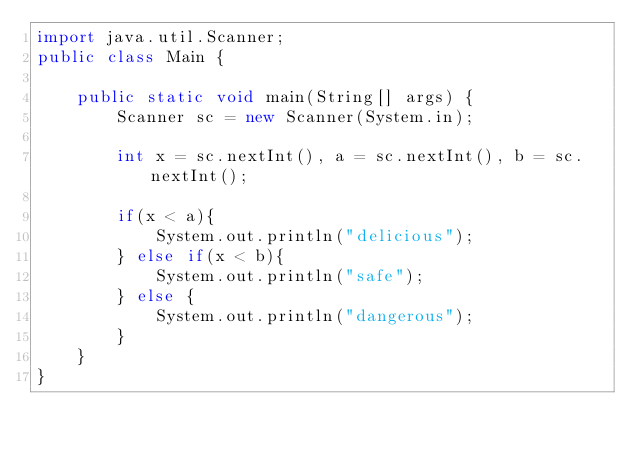<code> <loc_0><loc_0><loc_500><loc_500><_Java_>import java.util.Scanner;
public class Main {

    public static void main(String[] args) {
        Scanner sc = new Scanner(System.in);

        int x = sc.nextInt(), a = sc.nextInt(), b = sc.nextInt();

        if(x < a){
            System.out.println("delicious");
        } else if(x < b){
            System.out.println("safe");
        } else {
            System.out.println("dangerous");
        }
    }
}
</code> 